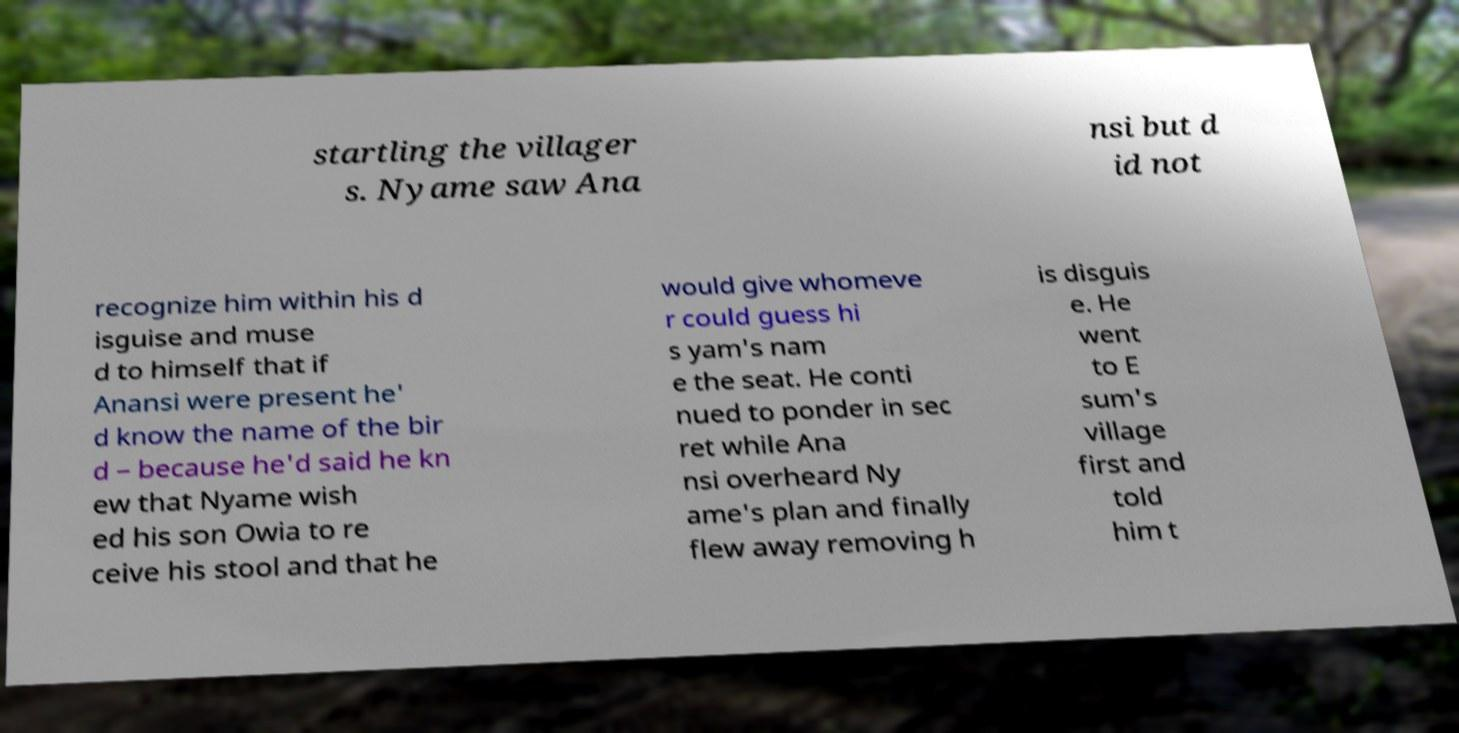Could you extract and type out the text from this image? startling the villager s. Nyame saw Ana nsi but d id not recognize him within his d isguise and muse d to himself that if Anansi were present he' d know the name of the bir d – because he'd said he kn ew that Nyame wish ed his son Owia to re ceive his stool and that he would give whomeve r could guess hi s yam's nam e the seat. He conti nued to ponder in sec ret while Ana nsi overheard Ny ame's plan and finally flew away removing h is disguis e. He went to E sum's village first and told him t 